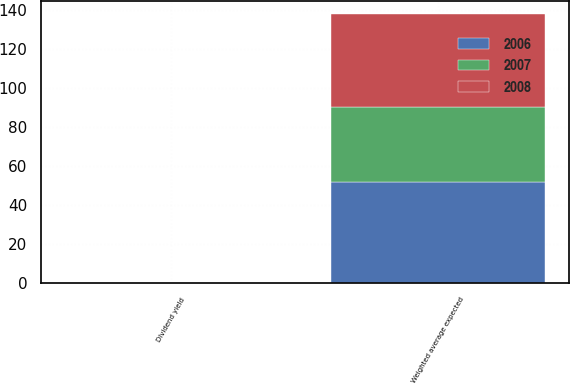Convert chart. <chart><loc_0><loc_0><loc_500><loc_500><stacked_bar_chart><ecel><fcel>Dividend yield<fcel>Weighted average expected<nl><fcel>2007<fcel>0<fcel>38.5<nl><fcel>2008<fcel>0<fcel>47.4<nl><fcel>2006<fcel>0<fcel>51.6<nl></chart> 